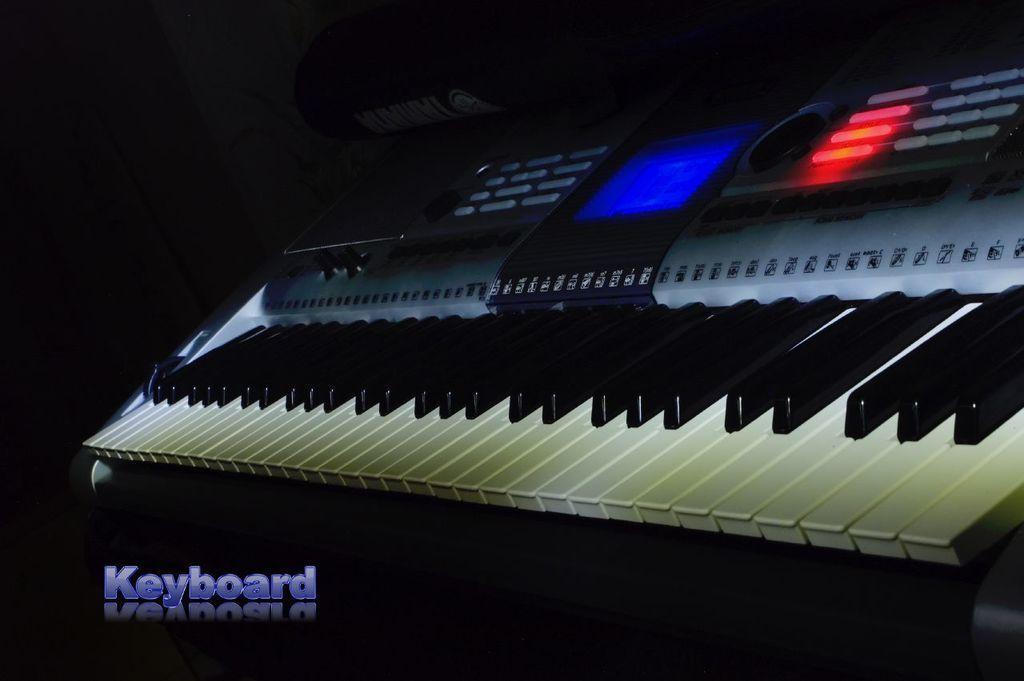Describe this image in one or two sentences. In this picture we can see a keyboard. 